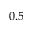Convert formula to latex. <formula><loc_0><loc_0><loc_500><loc_500>0 . 5</formula> 